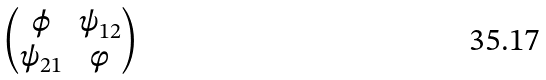<formula> <loc_0><loc_0><loc_500><loc_500>\begin{pmatrix} \phi & \psi _ { 1 2 } \\ \psi _ { 2 1 } & \varphi \end{pmatrix}</formula> 